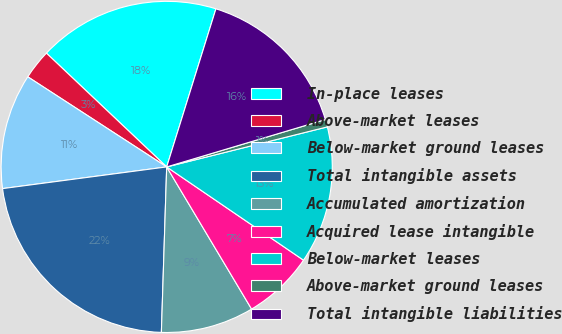Convert chart to OTSL. <chart><loc_0><loc_0><loc_500><loc_500><pie_chart><fcel>In-place leases<fcel>Above-market leases<fcel>Below-market ground leases<fcel>Total intangible assets<fcel>Accumulated amortization<fcel>Acquired lease intangible<fcel>Below-market leases<fcel>Above-market ground leases<fcel>Total intangible liabilities<nl><fcel>17.75%<fcel>2.9%<fcel>11.25%<fcel>22.4%<fcel>9.08%<fcel>6.91%<fcel>13.41%<fcel>0.73%<fcel>15.58%<nl></chart> 